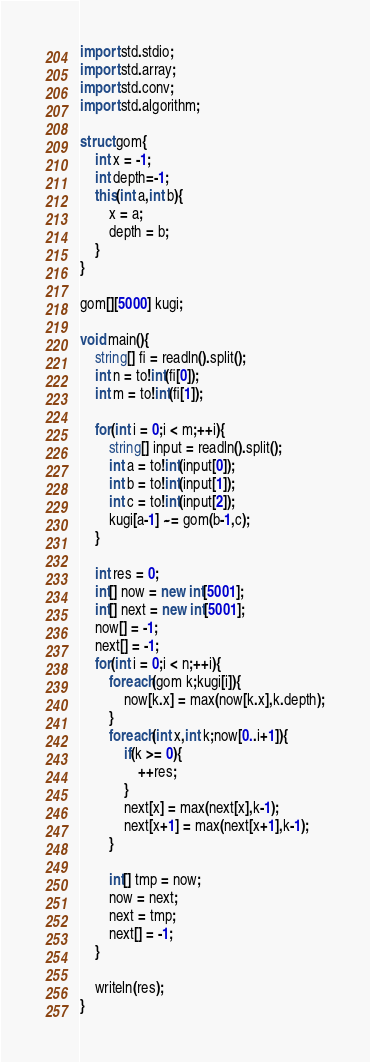<code> <loc_0><loc_0><loc_500><loc_500><_D_>import std.stdio;
import std.array;
import std.conv;
import std.algorithm;

struct gom{
	int x = -1;
	int depth=-1;
	this(int a,int b){
		x = a;
		depth = b;
	}
}

gom[][5000] kugi;

void main(){
	string[] fi = readln().split();
	int n = to!int(fi[0]);
	int m = to!int(fi[1]);

	for(int i = 0;i < m;++i){
		string[] input = readln().split();
		int a = to!int(input[0]);
		int b = to!int(input[1]);
		int c = to!int(input[2]);
		kugi[a-1] ~= gom(b-1,c);
	}

	int res = 0;
	int[] now = new int[5001];
	int[] next = new int[5001];
	now[] = -1;
	next[] = -1;
	for(int i = 0;i < n;++i){
		foreach(gom k;kugi[i]){
			now[k.x] = max(now[k.x],k.depth);
		}		
		foreach(int x,int k;now[0..i+1]){
			if(k >= 0){
				++res;
			}
			next[x] = max(next[x],k-1);
			next[x+1] = max(next[x+1],k-1);
		}

		int[] tmp = now;
		now = next;
		next = tmp;
		next[] = -1;
	}

	writeln(res);
}</code> 